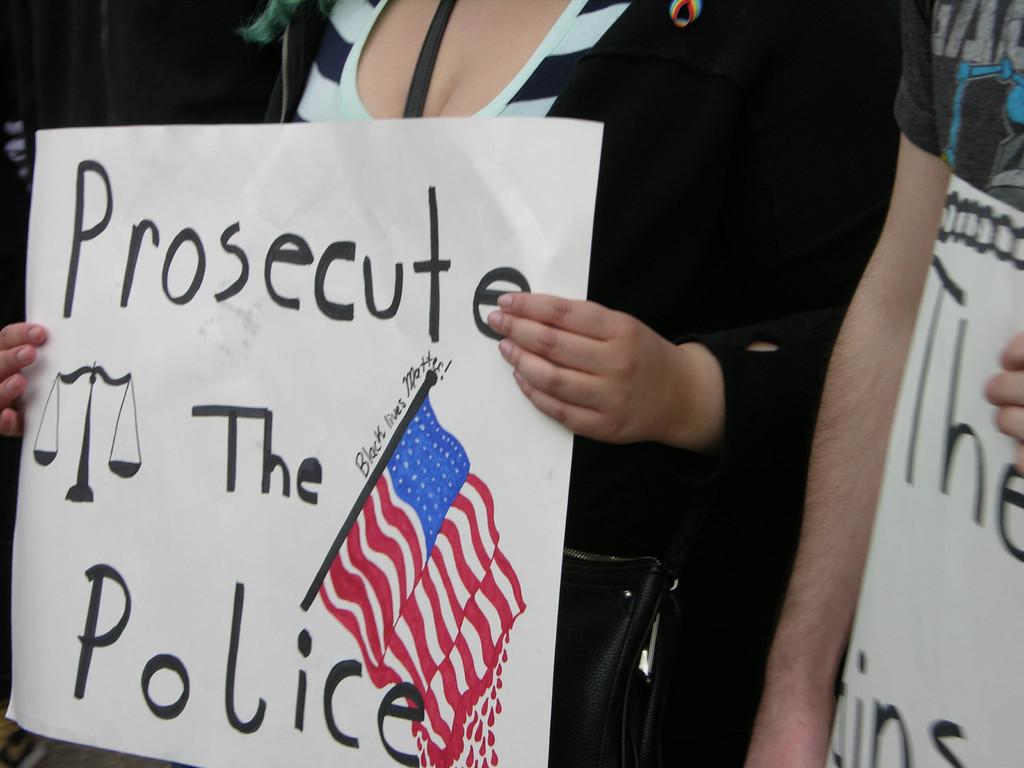Who should be prosecuted?
Provide a succinct answer. The police. What phrase is written along the flagpole?
Ensure brevity in your answer.  Prosecute the police. 